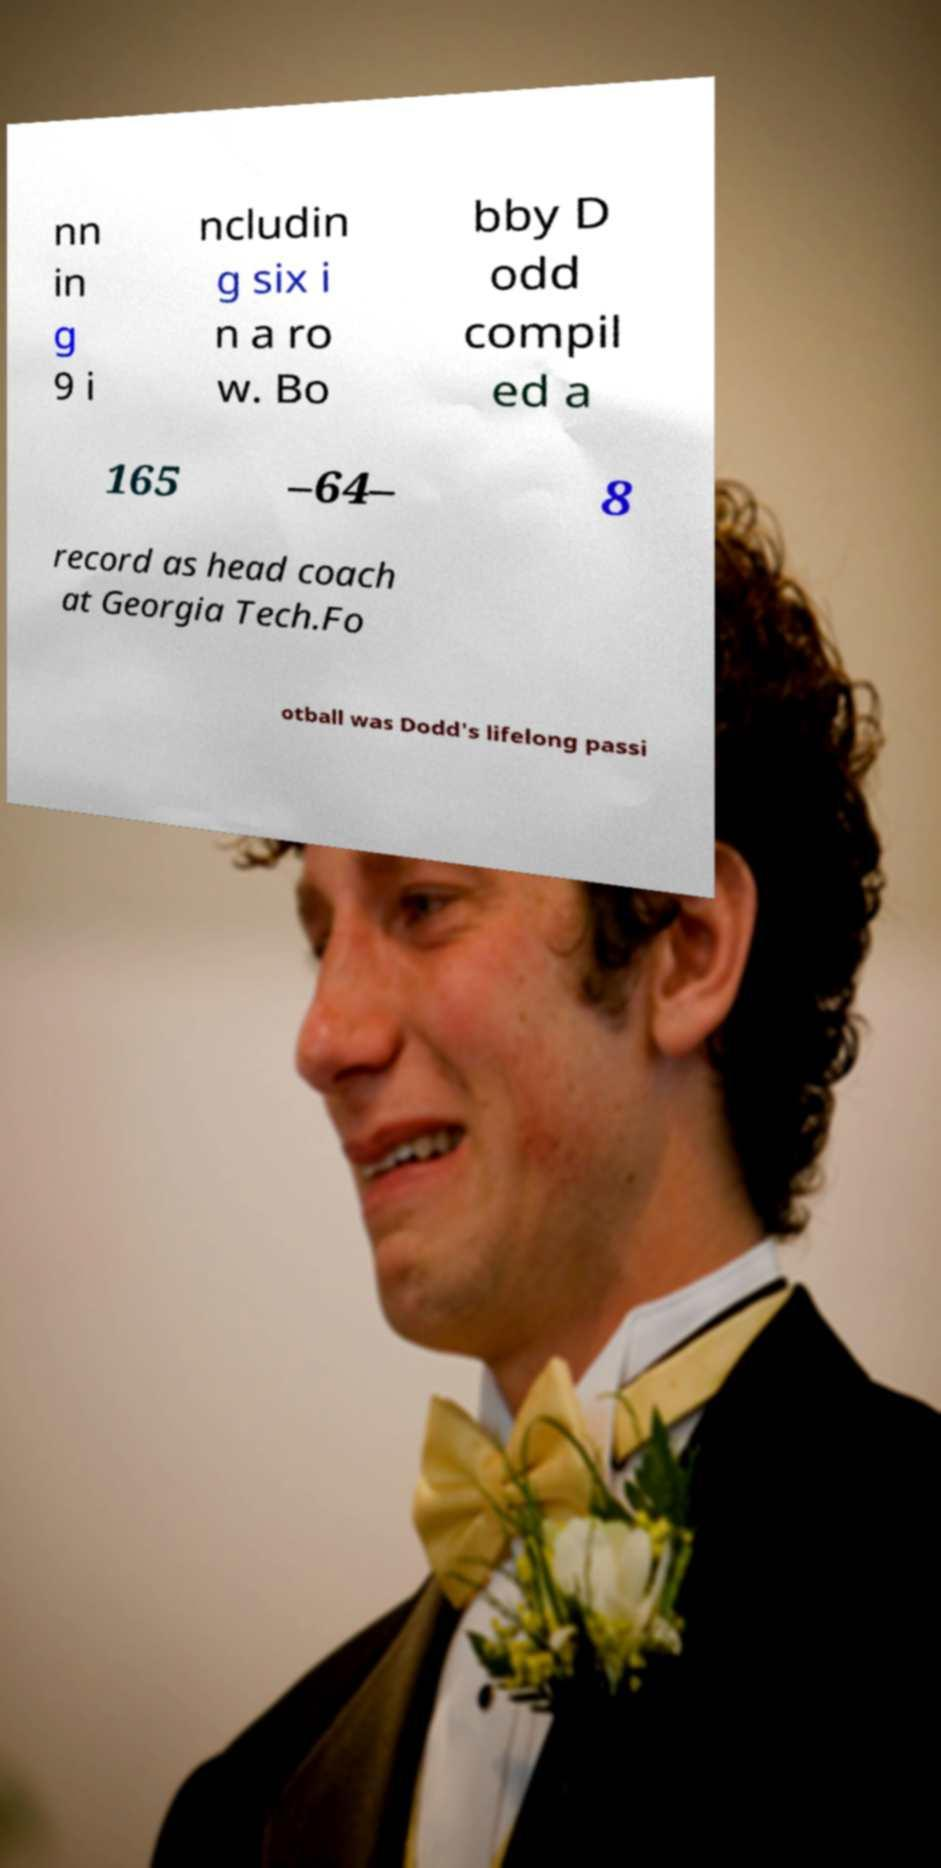Can you accurately transcribe the text from the provided image for me? nn in g 9 i ncludin g six i n a ro w. Bo bby D odd compil ed a 165 –64– 8 record as head coach at Georgia Tech.Fo otball was Dodd's lifelong passi 